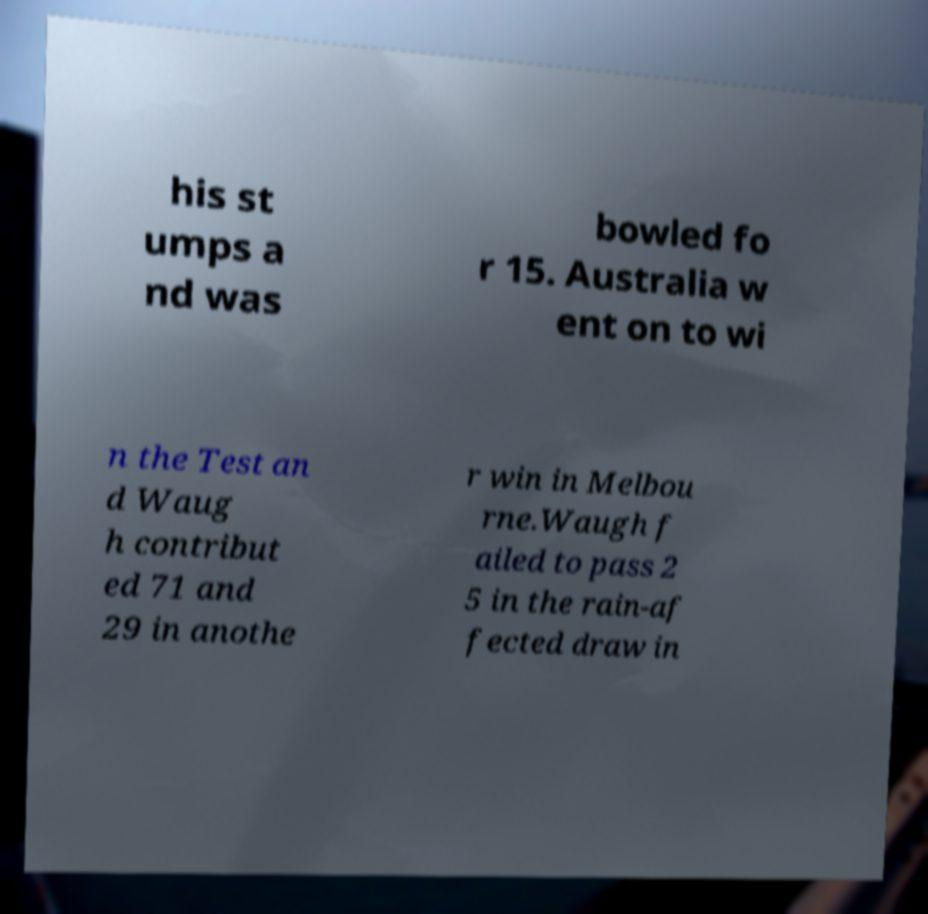Please read and relay the text visible in this image. What does it say? his st umps a nd was bowled fo r 15. Australia w ent on to wi n the Test an d Waug h contribut ed 71 and 29 in anothe r win in Melbou rne.Waugh f ailed to pass 2 5 in the rain-af fected draw in 